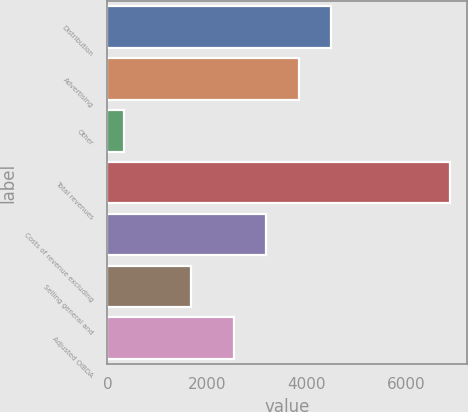<chart> <loc_0><loc_0><loc_500><loc_500><bar_chart><fcel>Distribution<fcel>Advertising<fcel>Other<fcel>Total revenues<fcel>Costs of revenue excluding<fcel>Selling general and<fcel>Adjusted OIBDA<nl><fcel>4495.1<fcel>3840.4<fcel>326<fcel>6873<fcel>3185.7<fcel>1686<fcel>2531<nl></chart> 